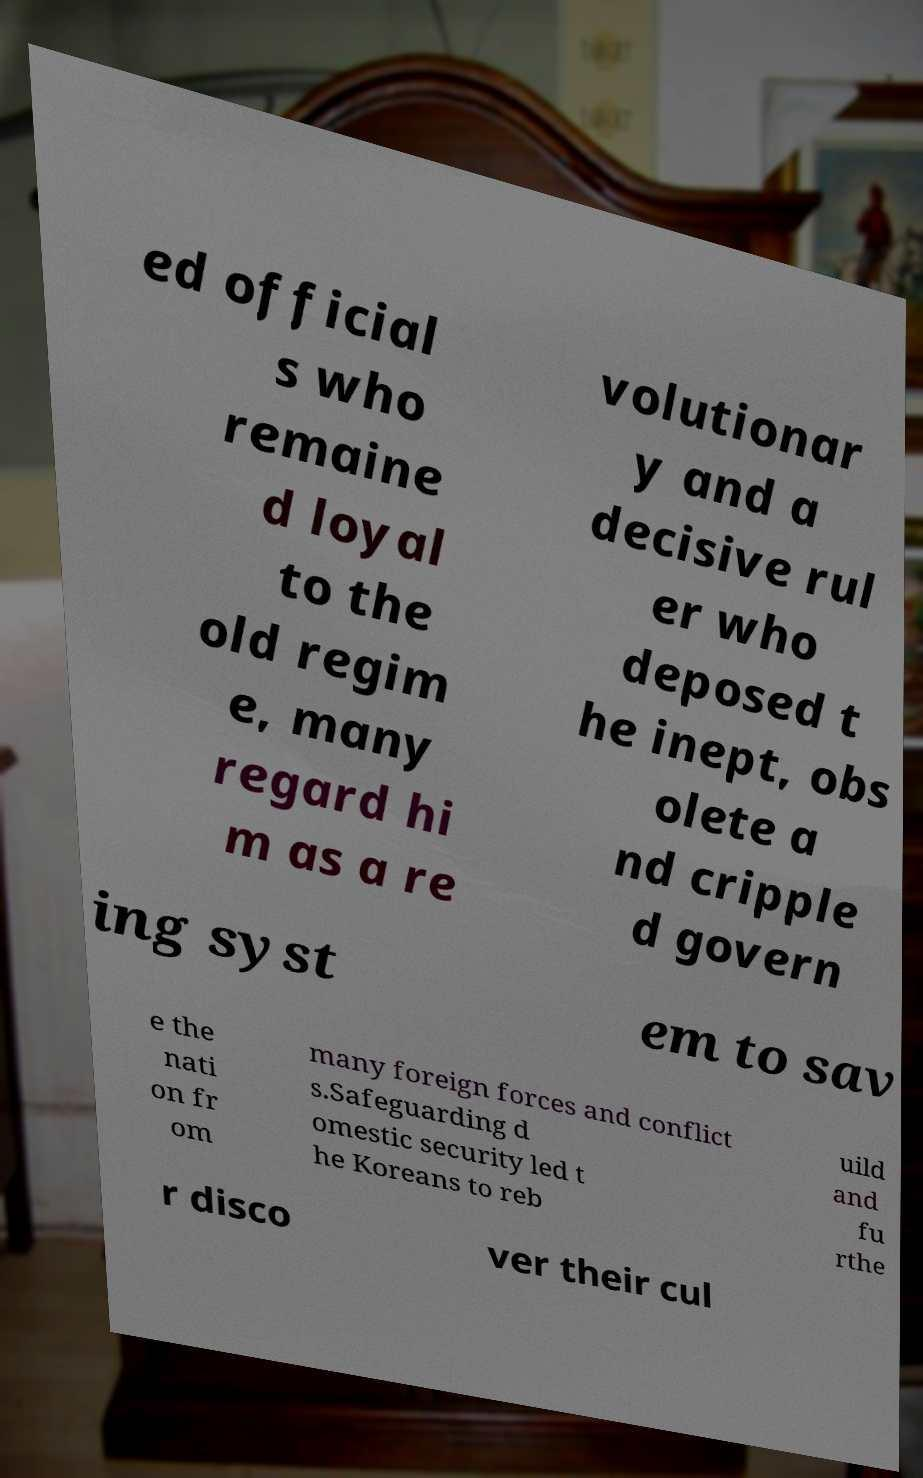There's text embedded in this image that I need extracted. Can you transcribe it verbatim? ed official s who remaine d loyal to the old regim e, many regard hi m as a re volutionar y and a decisive rul er who deposed t he inept, obs olete a nd cripple d govern ing syst em to sav e the nati on fr om many foreign forces and conflict s.Safeguarding d omestic security led t he Koreans to reb uild and fu rthe r disco ver their cul 